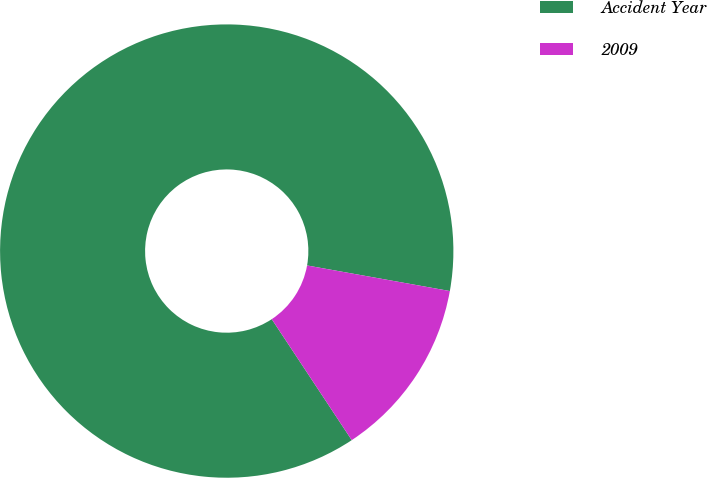Convert chart to OTSL. <chart><loc_0><loc_0><loc_500><loc_500><pie_chart><fcel>Accident Year<fcel>2009<nl><fcel>87.12%<fcel>12.88%<nl></chart> 